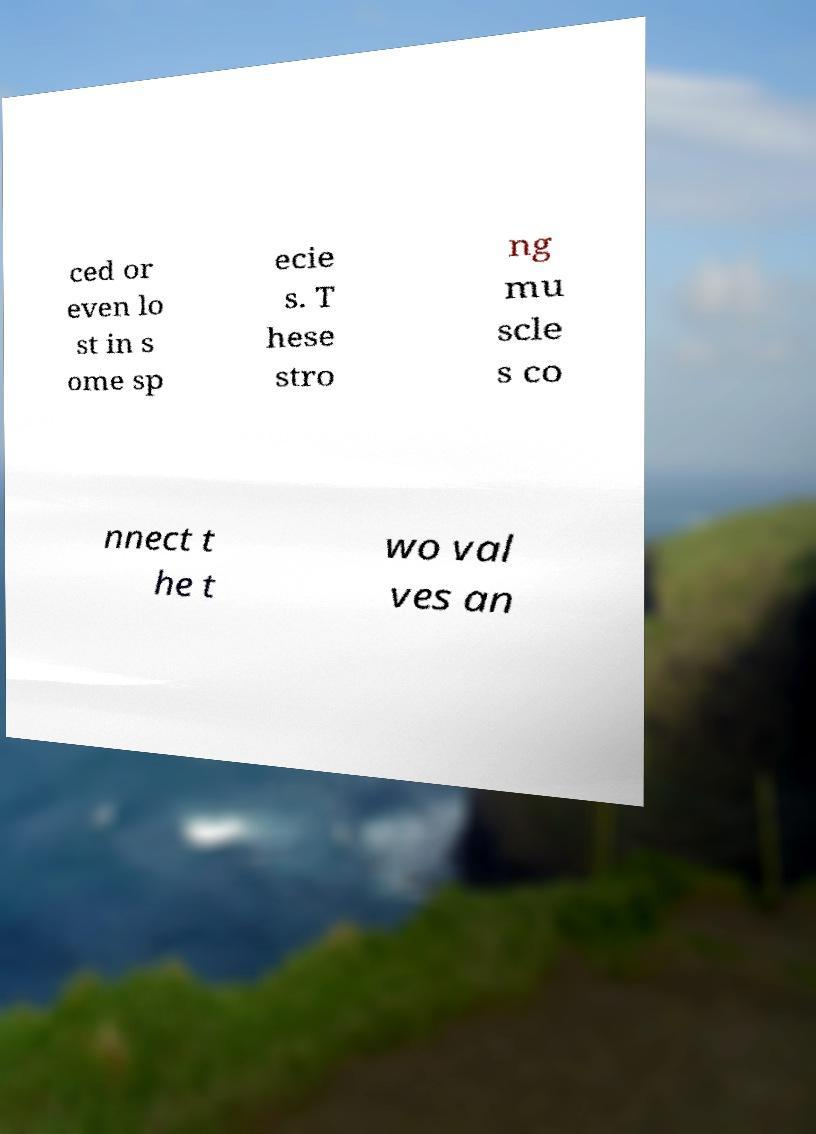Can you read and provide the text displayed in the image?This photo seems to have some interesting text. Can you extract and type it out for me? ced or even lo st in s ome sp ecie s. T hese stro ng mu scle s co nnect t he t wo val ves an 